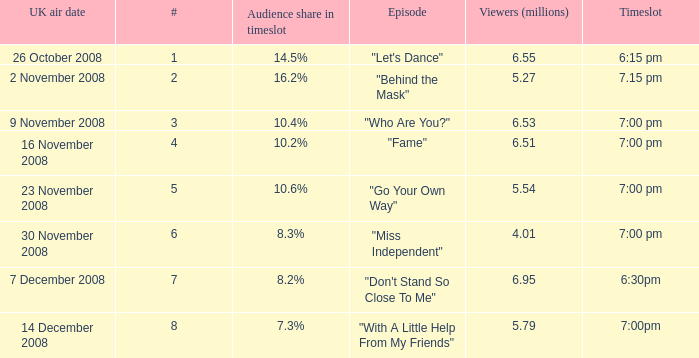Name the most number for viewers being 6.95 7.0. 